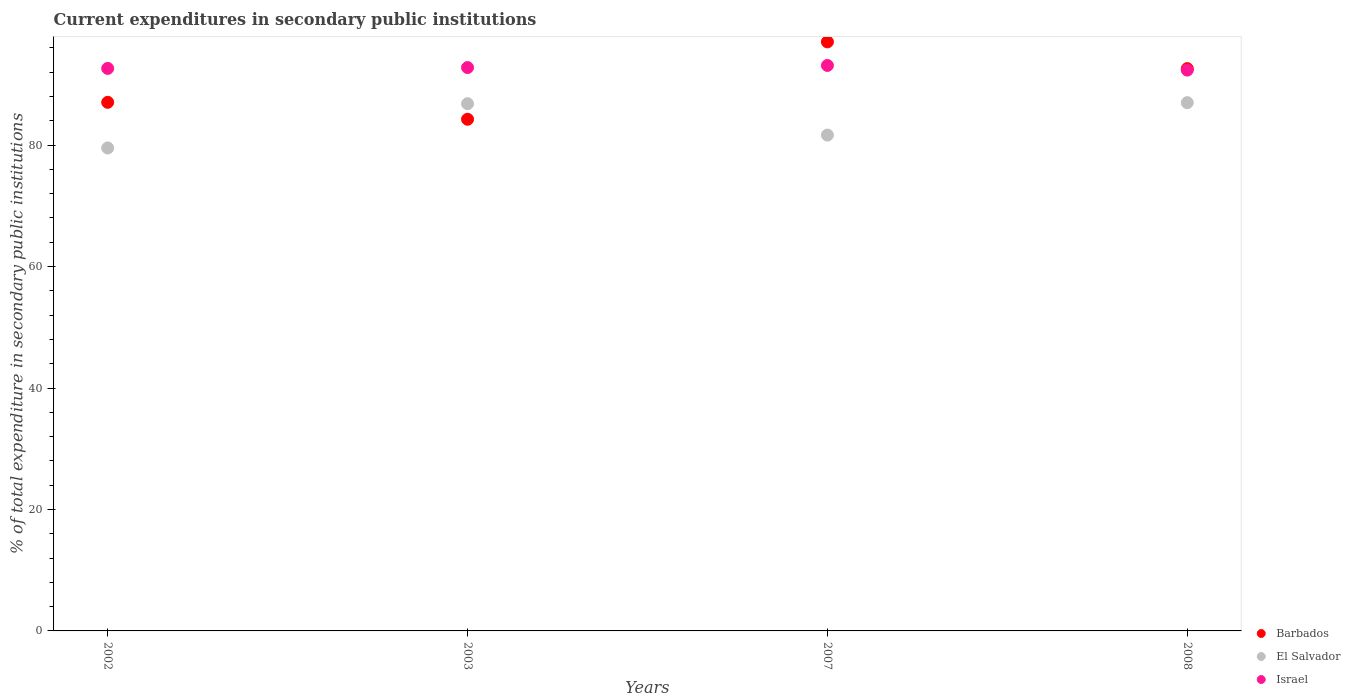Is the number of dotlines equal to the number of legend labels?
Give a very brief answer. Yes. What is the current expenditures in secondary public institutions in El Salvador in 2008?
Give a very brief answer. 86.98. Across all years, what is the maximum current expenditures in secondary public institutions in Barbados?
Your answer should be very brief. 96.99. Across all years, what is the minimum current expenditures in secondary public institutions in Israel?
Give a very brief answer. 92.35. What is the total current expenditures in secondary public institutions in Israel in the graph?
Offer a terse response. 370.85. What is the difference between the current expenditures in secondary public institutions in Israel in 2007 and that in 2008?
Your answer should be compact. 0.77. What is the difference between the current expenditures in secondary public institutions in Barbados in 2008 and the current expenditures in secondary public institutions in El Salvador in 2007?
Ensure brevity in your answer.  10.94. What is the average current expenditures in secondary public institutions in Barbados per year?
Your answer should be compact. 90.22. In the year 2003, what is the difference between the current expenditures in secondary public institutions in Israel and current expenditures in secondary public institutions in El Salvador?
Keep it short and to the point. 5.95. What is the ratio of the current expenditures in secondary public institutions in Barbados in 2003 to that in 2007?
Your answer should be compact. 0.87. Is the current expenditures in secondary public institutions in Barbados in 2002 less than that in 2007?
Offer a very short reply. Yes. What is the difference between the highest and the second highest current expenditures in secondary public institutions in Barbados?
Your answer should be very brief. 4.4. What is the difference between the highest and the lowest current expenditures in secondary public institutions in Barbados?
Your answer should be very brief. 12.74. Is the sum of the current expenditures in secondary public institutions in El Salvador in 2003 and 2008 greater than the maximum current expenditures in secondary public institutions in Barbados across all years?
Make the answer very short. Yes. Is the current expenditures in secondary public institutions in El Salvador strictly greater than the current expenditures in secondary public institutions in Israel over the years?
Provide a short and direct response. No. How many dotlines are there?
Your response must be concise. 3. What is the difference between two consecutive major ticks on the Y-axis?
Keep it short and to the point. 20. Are the values on the major ticks of Y-axis written in scientific E-notation?
Provide a short and direct response. No. Where does the legend appear in the graph?
Your response must be concise. Bottom right. What is the title of the graph?
Make the answer very short. Current expenditures in secondary public institutions. What is the label or title of the Y-axis?
Your answer should be very brief. % of total expenditure in secondary public institutions. What is the % of total expenditure in secondary public institutions in Barbados in 2002?
Provide a short and direct response. 87.04. What is the % of total expenditure in secondary public institutions of El Salvador in 2002?
Your answer should be compact. 79.53. What is the % of total expenditure in secondary public institutions in Israel in 2002?
Offer a terse response. 92.62. What is the % of total expenditure in secondary public institutions of Barbados in 2003?
Provide a succinct answer. 84.25. What is the % of total expenditure in secondary public institutions in El Salvador in 2003?
Provide a short and direct response. 86.81. What is the % of total expenditure in secondary public institutions in Israel in 2003?
Provide a short and direct response. 92.77. What is the % of total expenditure in secondary public institutions in Barbados in 2007?
Provide a short and direct response. 96.99. What is the % of total expenditure in secondary public institutions of El Salvador in 2007?
Make the answer very short. 81.65. What is the % of total expenditure in secondary public institutions of Israel in 2007?
Your answer should be compact. 93.11. What is the % of total expenditure in secondary public institutions in Barbados in 2008?
Give a very brief answer. 92.59. What is the % of total expenditure in secondary public institutions of El Salvador in 2008?
Keep it short and to the point. 86.98. What is the % of total expenditure in secondary public institutions of Israel in 2008?
Offer a very short reply. 92.35. Across all years, what is the maximum % of total expenditure in secondary public institutions in Barbados?
Make the answer very short. 96.99. Across all years, what is the maximum % of total expenditure in secondary public institutions of El Salvador?
Offer a terse response. 86.98. Across all years, what is the maximum % of total expenditure in secondary public institutions of Israel?
Offer a very short reply. 93.11. Across all years, what is the minimum % of total expenditure in secondary public institutions of Barbados?
Make the answer very short. 84.25. Across all years, what is the minimum % of total expenditure in secondary public institutions of El Salvador?
Make the answer very short. 79.53. Across all years, what is the minimum % of total expenditure in secondary public institutions of Israel?
Keep it short and to the point. 92.35. What is the total % of total expenditure in secondary public institutions in Barbados in the graph?
Offer a terse response. 360.88. What is the total % of total expenditure in secondary public institutions of El Salvador in the graph?
Give a very brief answer. 334.97. What is the total % of total expenditure in secondary public institutions in Israel in the graph?
Keep it short and to the point. 370.85. What is the difference between the % of total expenditure in secondary public institutions of Barbados in 2002 and that in 2003?
Give a very brief answer. 2.79. What is the difference between the % of total expenditure in secondary public institutions in El Salvador in 2002 and that in 2003?
Offer a very short reply. -7.29. What is the difference between the % of total expenditure in secondary public institutions of Israel in 2002 and that in 2003?
Make the answer very short. -0.14. What is the difference between the % of total expenditure in secondary public institutions of Barbados in 2002 and that in 2007?
Provide a succinct answer. -9.95. What is the difference between the % of total expenditure in secondary public institutions of El Salvador in 2002 and that in 2007?
Make the answer very short. -2.12. What is the difference between the % of total expenditure in secondary public institutions in Israel in 2002 and that in 2007?
Your answer should be compact. -0.49. What is the difference between the % of total expenditure in secondary public institutions in Barbados in 2002 and that in 2008?
Make the answer very short. -5.55. What is the difference between the % of total expenditure in secondary public institutions in El Salvador in 2002 and that in 2008?
Give a very brief answer. -7.46. What is the difference between the % of total expenditure in secondary public institutions in Israel in 2002 and that in 2008?
Make the answer very short. 0.28. What is the difference between the % of total expenditure in secondary public institutions of Barbados in 2003 and that in 2007?
Your answer should be compact. -12.74. What is the difference between the % of total expenditure in secondary public institutions of El Salvador in 2003 and that in 2007?
Your answer should be compact. 5.16. What is the difference between the % of total expenditure in secondary public institutions of Israel in 2003 and that in 2007?
Ensure brevity in your answer.  -0.35. What is the difference between the % of total expenditure in secondary public institutions in Barbados in 2003 and that in 2008?
Keep it short and to the point. -8.34. What is the difference between the % of total expenditure in secondary public institutions in El Salvador in 2003 and that in 2008?
Keep it short and to the point. -0.17. What is the difference between the % of total expenditure in secondary public institutions of Israel in 2003 and that in 2008?
Provide a succinct answer. 0.42. What is the difference between the % of total expenditure in secondary public institutions in Barbados in 2007 and that in 2008?
Your answer should be very brief. 4.4. What is the difference between the % of total expenditure in secondary public institutions of El Salvador in 2007 and that in 2008?
Provide a succinct answer. -5.34. What is the difference between the % of total expenditure in secondary public institutions of Israel in 2007 and that in 2008?
Your answer should be very brief. 0.77. What is the difference between the % of total expenditure in secondary public institutions of Barbados in 2002 and the % of total expenditure in secondary public institutions of El Salvador in 2003?
Offer a terse response. 0.23. What is the difference between the % of total expenditure in secondary public institutions in Barbados in 2002 and the % of total expenditure in secondary public institutions in Israel in 2003?
Offer a very short reply. -5.72. What is the difference between the % of total expenditure in secondary public institutions of El Salvador in 2002 and the % of total expenditure in secondary public institutions of Israel in 2003?
Your answer should be compact. -13.24. What is the difference between the % of total expenditure in secondary public institutions in Barbados in 2002 and the % of total expenditure in secondary public institutions in El Salvador in 2007?
Your response must be concise. 5.39. What is the difference between the % of total expenditure in secondary public institutions of Barbados in 2002 and the % of total expenditure in secondary public institutions of Israel in 2007?
Your answer should be compact. -6.07. What is the difference between the % of total expenditure in secondary public institutions of El Salvador in 2002 and the % of total expenditure in secondary public institutions of Israel in 2007?
Provide a short and direct response. -13.59. What is the difference between the % of total expenditure in secondary public institutions of Barbados in 2002 and the % of total expenditure in secondary public institutions of El Salvador in 2008?
Offer a terse response. 0.06. What is the difference between the % of total expenditure in secondary public institutions of Barbados in 2002 and the % of total expenditure in secondary public institutions of Israel in 2008?
Offer a very short reply. -5.31. What is the difference between the % of total expenditure in secondary public institutions in El Salvador in 2002 and the % of total expenditure in secondary public institutions in Israel in 2008?
Ensure brevity in your answer.  -12.82. What is the difference between the % of total expenditure in secondary public institutions in Barbados in 2003 and the % of total expenditure in secondary public institutions in El Salvador in 2007?
Keep it short and to the point. 2.6. What is the difference between the % of total expenditure in secondary public institutions in Barbados in 2003 and the % of total expenditure in secondary public institutions in Israel in 2007?
Provide a short and direct response. -8.86. What is the difference between the % of total expenditure in secondary public institutions of El Salvador in 2003 and the % of total expenditure in secondary public institutions of Israel in 2007?
Make the answer very short. -6.3. What is the difference between the % of total expenditure in secondary public institutions of Barbados in 2003 and the % of total expenditure in secondary public institutions of El Salvador in 2008?
Your answer should be compact. -2.73. What is the difference between the % of total expenditure in secondary public institutions of Barbados in 2003 and the % of total expenditure in secondary public institutions of Israel in 2008?
Your response must be concise. -8.1. What is the difference between the % of total expenditure in secondary public institutions of El Salvador in 2003 and the % of total expenditure in secondary public institutions of Israel in 2008?
Provide a short and direct response. -5.53. What is the difference between the % of total expenditure in secondary public institutions in Barbados in 2007 and the % of total expenditure in secondary public institutions in El Salvador in 2008?
Provide a short and direct response. 10.01. What is the difference between the % of total expenditure in secondary public institutions in Barbados in 2007 and the % of total expenditure in secondary public institutions in Israel in 2008?
Provide a short and direct response. 4.65. What is the difference between the % of total expenditure in secondary public institutions of El Salvador in 2007 and the % of total expenditure in secondary public institutions of Israel in 2008?
Keep it short and to the point. -10.7. What is the average % of total expenditure in secondary public institutions of Barbados per year?
Your response must be concise. 90.22. What is the average % of total expenditure in secondary public institutions of El Salvador per year?
Your answer should be compact. 83.74. What is the average % of total expenditure in secondary public institutions in Israel per year?
Give a very brief answer. 92.71. In the year 2002, what is the difference between the % of total expenditure in secondary public institutions of Barbados and % of total expenditure in secondary public institutions of El Salvador?
Your answer should be compact. 7.52. In the year 2002, what is the difference between the % of total expenditure in secondary public institutions of Barbados and % of total expenditure in secondary public institutions of Israel?
Keep it short and to the point. -5.58. In the year 2002, what is the difference between the % of total expenditure in secondary public institutions of El Salvador and % of total expenditure in secondary public institutions of Israel?
Provide a succinct answer. -13.1. In the year 2003, what is the difference between the % of total expenditure in secondary public institutions in Barbados and % of total expenditure in secondary public institutions in El Salvador?
Your answer should be compact. -2.56. In the year 2003, what is the difference between the % of total expenditure in secondary public institutions in Barbados and % of total expenditure in secondary public institutions in Israel?
Provide a succinct answer. -8.51. In the year 2003, what is the difference between the % of total expenditure in secondary public institutions of El Salvador and % of total expenditure in secondary public institutions of Israel?
Your answer should be compact. -5.95. In the year 2007, what is the difference between the % of total expenditure in secondary public institutions in Barbados and % of total expenditure in secondary public institutions in El Salvador?
Provide a short and direct response. 15.34. In the year 2007, what is the difference between the % of total expenditure in secondary public institutions of Barbados and % of total expenditure in secondary public institutions of Israel?
Provide a succinct answer. 3.88. In the year 2007, what is the difference between the % of total expenditure in secondary public institutions of El Salvador and % of total expenditure in secondary public institutions of Israel?
Make the answer very short. -11.46. In the year 2008, what is the difference between the % of total expenditure in secondary public institutions in Barbados and % of total expenditure in secondary public institutions in El Salvador?
Provide a succinct answer. 5.61. In the year 2008, what is the difference between the % of total expenditure in secondary public institutions of Barbados and % of total expenditure in secondary public institutions of Israel?
Your answer should be very brief. 0.25. In the year 2008, what is the difference between the % of total expenditure in secondary public institutions in El Salvador and % of total expenditure in secondary public institutions in Israel?
Provide a short and direct response. -5.36. What is the ratio of the % of total expenditure in secondary public institutions in Barbados in 2002 to that in 2003?
Make the answer very short. 1.03. What is the ratio of the % of total expenditure in secondary public institutions in El Salvador in 2002 to that in 2003?
Ensure brevity in your answer.  0.92. What is the ratio of the % of total expenditure in secondary public institutions of Israel in 2002 to that in 2003?
Ensure brevity in your answer.  1. What is the ratio of the % of total expenditure in secondary public institutions in Barbados in 2002 to that in 2007?
Provide a succinct answer. 0.9. What is the ratio of the % of total expenditure in secondary public institutions of El Salvador in 2002 to that in 2007?
Give a very brief answer. 0.97. What is the ratio of the % of total expenditure in secondary public institutions in Israel in 2002 to that in 2007?
Your answer should be very brief. 0.99. What is the ratio of the % of total expenditure in secondary public institutions of Barbados in 2002 to that in 2008?
Keep it short and to the point. 0.94. What is the ratio of the % of total expenditure in secondary public institutions of El Salvador in 2002 to that in 2008?
Keep it short and to the point. 0.91. What is the ratio of the % of total expenditure in secondary public institutions in Israel in 2002 to that in 2008?
Your answer should be compact. 1. What is the ratio of the % of total expenditure in secondary public institutions in Barbados in 2003 to that in 2007?
Give a very brief answer. 0.87. What is the ratio of the % of total expenditure in secondary public institutions of El Salvador in 2003 to that in 2007?
Make the answer very short. 1.06. What is the ratio of the % of total expenditure in secondary public institutions of Barbados in 2003 to that in 2008?
Ensure brevity in your answer.  0.91. What is the ratio of the % of total expenditure in secondary public institutions in Israel in 2003 to that in 2008?
Offer a terse response. 1. What is the ratio of the % of total expenditure in secondary public institutions of Barbados in 2007 to that in 2008?
Your answer should be compact. 1.05. What is the ratio of the % of total expenditure in secondary public institutions in El Salvador in 2007 to that in 2008?
Offer a very short reply. 0.94. What is the ratio of the % of total expenditure in secondary public institutions of Israel in 2007 to that in 2008?
Offer a very short reply. 1.01. What is the difference between the highest and the second highest % of total expenditure in secondary public institutions in Barbados?
Keep it short and to the point. 4.4. What is the difference between the highest and the second highest % of total expenditure in secondary public institutions in El Salvador?
Offer a very short reply. 0.17. What is the difference between the highest and the second highest % of total expenditure in secondary public institutions in Israel?
Provide a short and direct response. 0.35. What is the difference between the highest and the lowest % of total expenditure in secondary public institutions of Barbados?
Give a very brief answer. 12.74. What is the difference between the highest and the lowest % of total expenditure in secondary public institutions of El Salvador?
Provide a short and direct response. 7.46. What is the difference between the highest and the lowest % of total expenditure in secondary public institutions in Israel?
Offer a terse response. 0.77. 